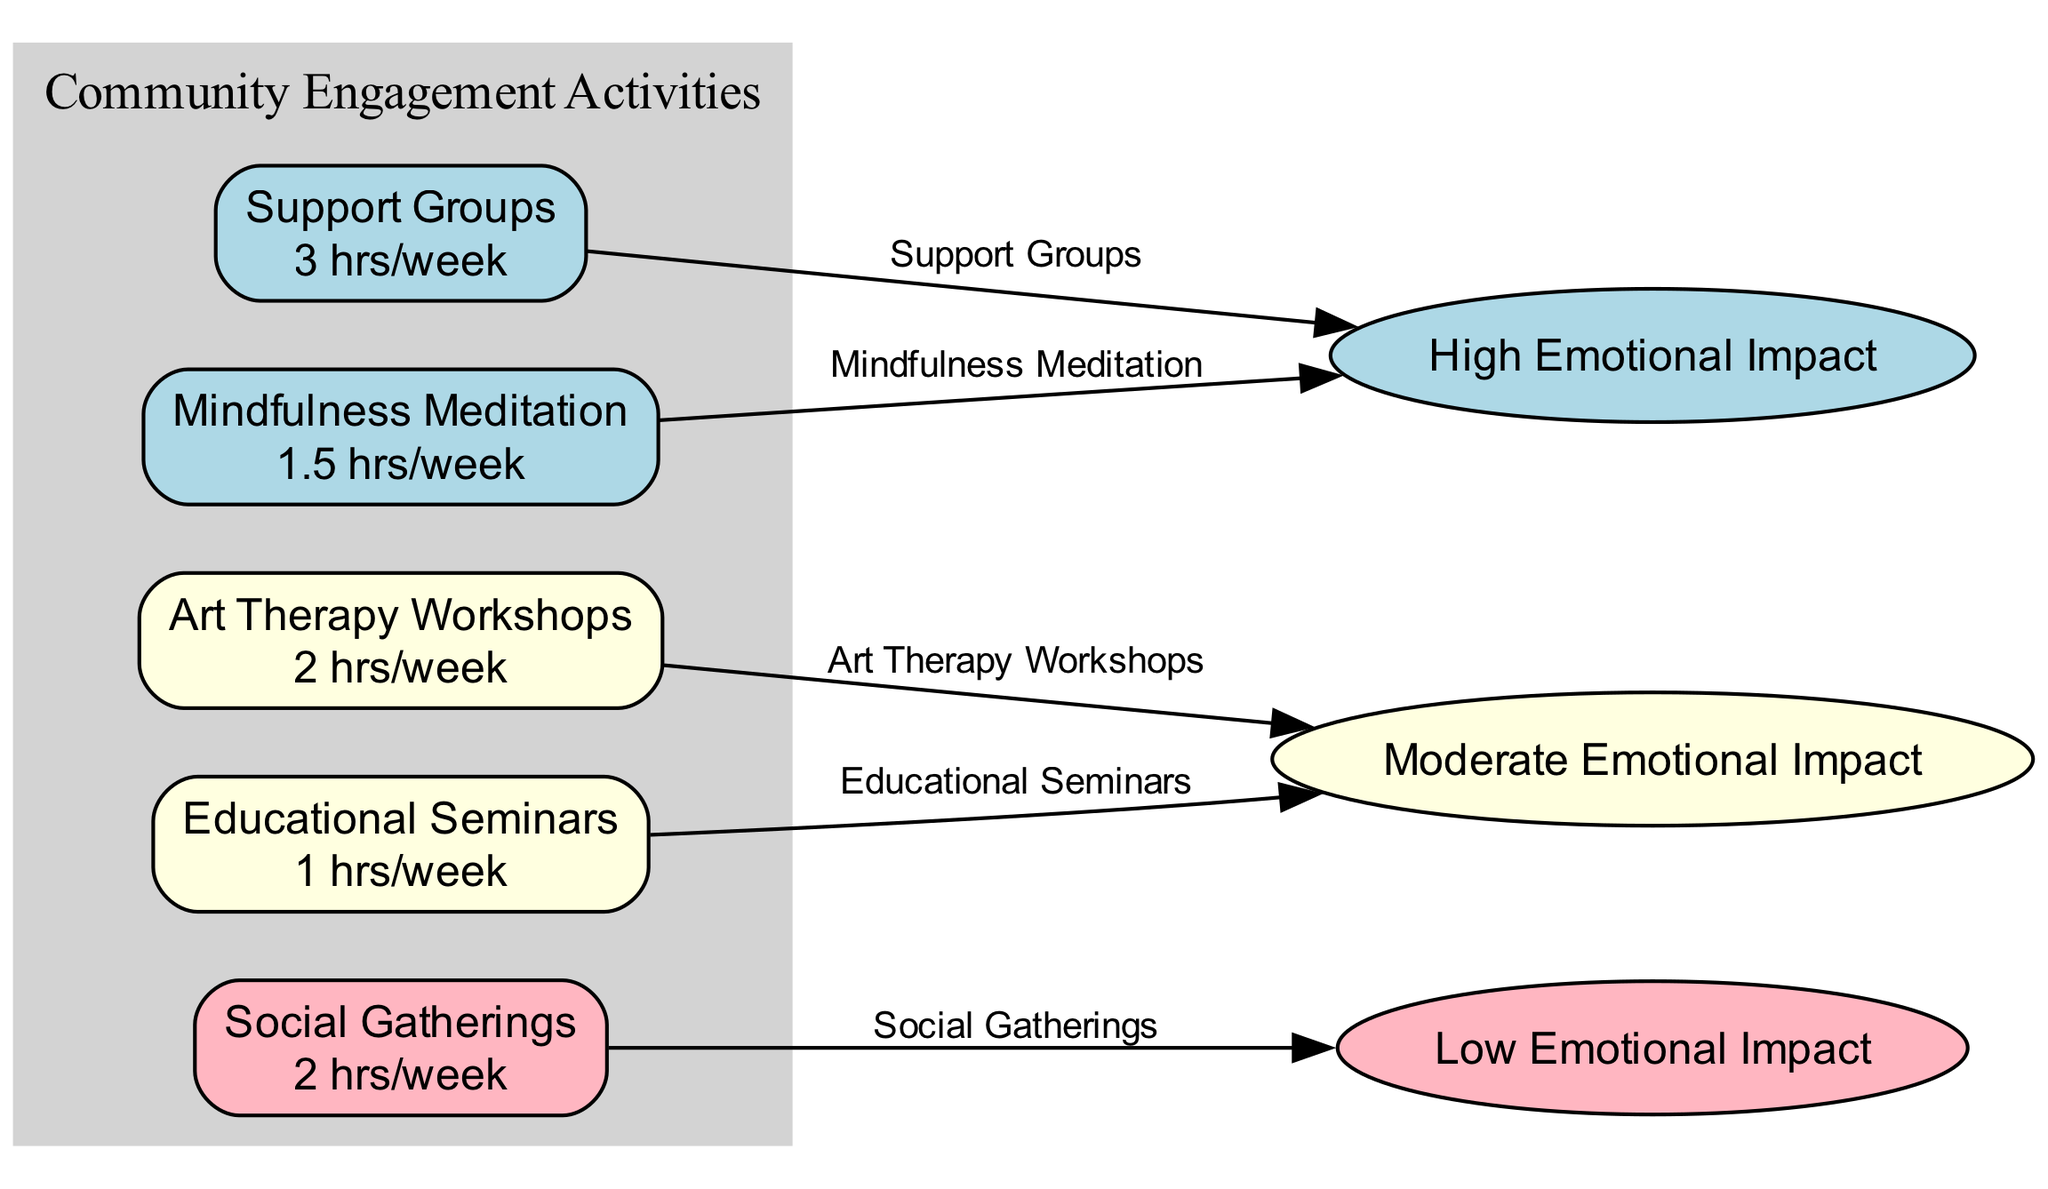What is the emotional impact category for support groups? The diagram indicates that support groups are linked to the "High Emotional Impact" category. This is displayed directly by the edge labeled "Support Groups" connecting to the impact category.
Answer: High How many hours per week are dedicated to art therapy workshops? According to the node labeled "Art Therapy Workshops," it states there are 2 hours spent per week engaging in this activity.
Answer: 2 hours Which activity has a low emotional impact? From the edges leading to the impact categories, the "Social Gatherings" activity is labeled as connecting to the "Low Emotional Impact" category. Therefore, it is the only activity in that group.
Answer: Social Gatherings What is the common emotional impact level for mindfulness meditation? Mindfulness meditation is connected by an edge to the "High Emotional Impact" category, indicating that it strongly influences emotional wellness.
Answer: High Which activity has the highest hours spent per week? By comparing the hours spent across all activities, we see that "Support Groups" has the highest at 3 hours per week.
Answer: 3 hours How many total emotional impact categories are represented in the diagram? The diagram displays three distinct emotional impact categories: High, Moderate, and Low. This can be determined by counting the impact nodes linked from the activities.
Answer: 3 What activity is associated with moderate emotional impact but lower hours spent compared to support groups? The "Educational Seminars" and "Art Therapy Workshops" both have a moderate impact, but "Educational Seminars" has less hours at 1 hour, compared to the 3 hours of "Support Groups." This relationship reveals that different activities may have varied engagement levels and emotional benefits.
Answer: Educational Seminars What is the emotional impact along with time spent of mindfulness meditation? Mindfulness meditation is linked to the "High Emotional Impact" category and notes a commitment of 1.5 hours each week, showcasing both the significance of the time invested and the efficacy in emotional wellness.
Answer: High, 1.5 hours 